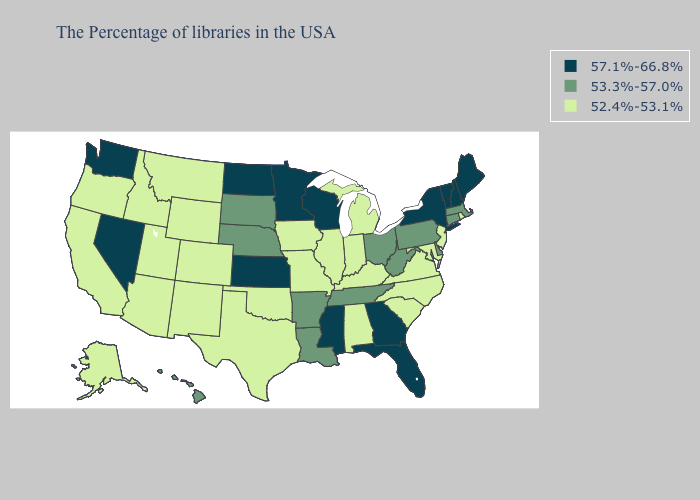Does the map have missing data?
Write a very short answer. No. Does Tennessee have the lowest value in the USA?
Be succinct. No. Among the states that border Texas , which have the lowest value?
Quick response, please. Oklahoma, New Mexico. Does Virginia have the lowest value in the South?
Answer briefly. Yes. Does Maryland have a lower value than Ohio?
Concise answer only. Yes. What is the lowest value in states that border Missouri?
Be succinct. 52.4%-53.1%. Name the states that have a value in the range 57.1%-66.8%?
Answer briefly. Maine, New Hampshire, Vermont, New York, Florida, Georgia, Wisconsin, Mississippi, Minnesota, Kansas, North Dakota, Nevada, Washington. Name the states that have a value in the range 57.1%-66.8%?
Concise answer only. Maine, New Hampshire, Vermont, New York, Florida, Georgia, Wisconsin, Mississippi, Minnesota, Kansas, North Dakota, Nevada, Washington. What is the value of Idaho?
Be succinct. 52.4%-53.1%. What is the value of Kentucky?
Answer briefly. 52.4%-53.1%. Is the legend a continuous bar?
Give a very brief answer. No. Among the states that border Ohio , which have the highest value?
Concise answer only. Pennsylvania, West Virginia. What is the lowest value in the USA?
Write a very short answer. 52.4%-53.1%. Which states hav the highest value in the West?
Write a very short answer. Nevada, Washington. Does the first symbol in the legend represent the smallest category?
Answer briefly. No. 